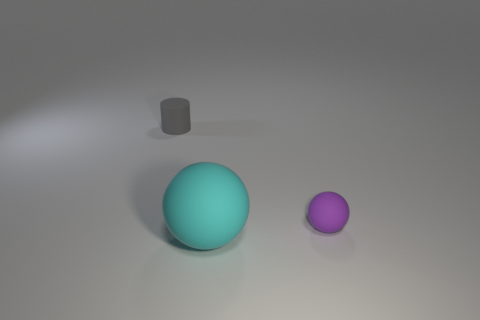Add 1 cyan matte things. How many objects exist? 4 Subtract all balls. How many objects are left? 1 Subtract 0 red cubes. How many objects are left? 3 Subtract all tiny purple matte balls. Subtract all large cyan spheres. How many objects are left? 1 Add 2 large objects. How many large objects are left? 3 Add 3 green shiny balls. How many green shiny balls exist? 3 